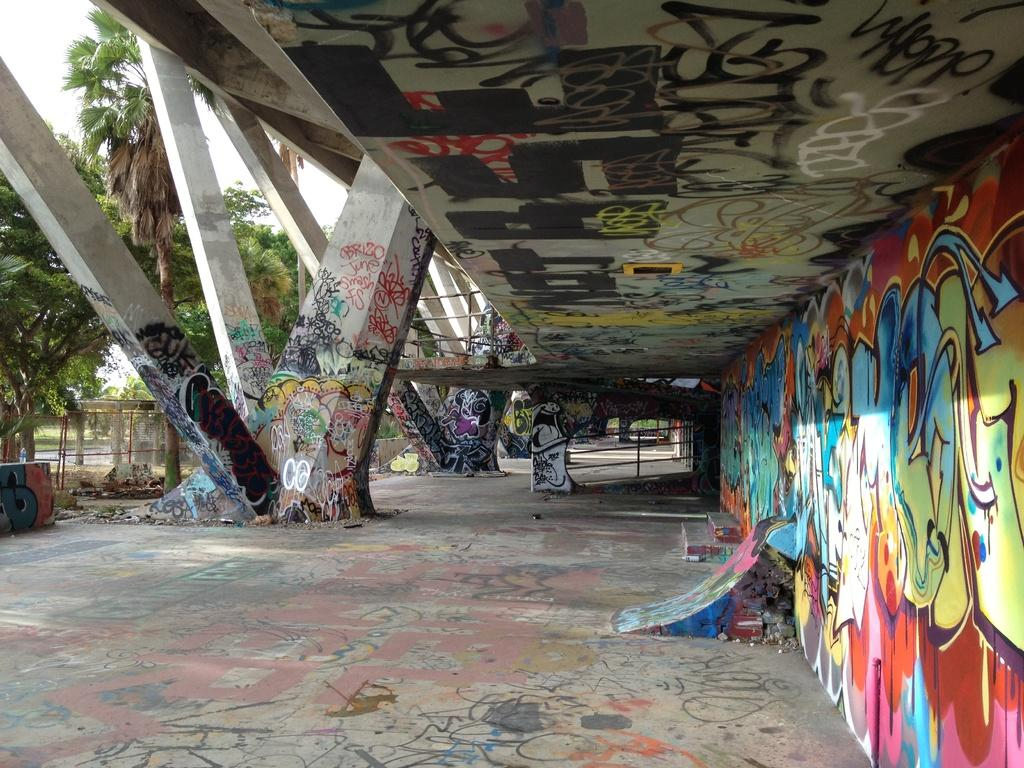What type of artwork can be seen on the wall in the image? There is graffiti on the wall in the image. Where else can graffiti be found in the image? Graffiti can also be found on the ceiling and pillars in the image. What architectural feature is present in the image? There are railings in the image. What type of vegetation is on the left side of the image? There are trees on the left side of the image. How does the graffiti react to the earthquake in the image? There is no earthquake present in the image, so the graffiti's reaction cannot be determined. What type of wind can be seen blowing through the playground in the image? There is no playground present in the image, so the type of wind cannot be determined. 